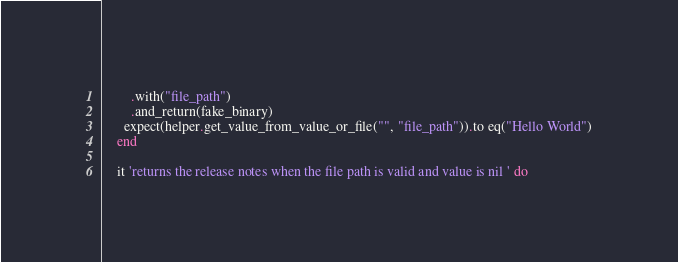Convert code to text. <code><loc_0><loc_0><loc_500><loc_500><_Ruby_>        .with("file_path")
        .and_return(fake_binary)
      expect(helper.get_value_from_value_or_file("", "file_path")).to eq("Hello World")
    end

    it 'returns the release notes when the file path is valid and value is nil ' do</code> 